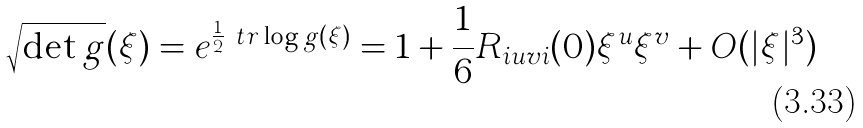Convert formula to latex. <formula><loc_0><loc_0><loc_500><loc_500>\sqrt { \det g } ( \xi ) = e ^ { \frac { 1 } { 2 } \ t r \log g ( \xi ) } = 1 + \frac { 1 } { 6 } R _ { i u v i } ( 0 ) \xi ^ { u } \xi ^ { v } + O ( | \xi | ^ { 3 } )</formula> 